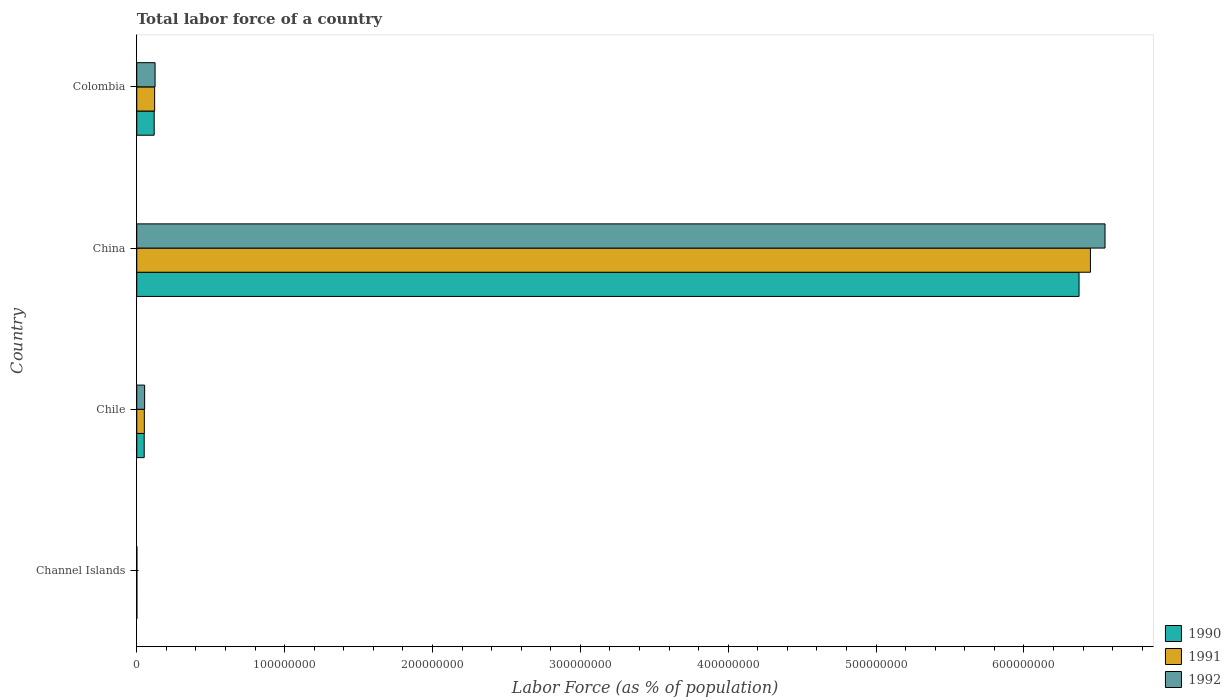How many bars are there on the 1st tick from the bottom?
Provide a succinct answer. 3. What is the percentage of labor force in 1990 in Colombia?
Offer a terse response. 1.18e+07. Across all countries, what is the maximum percentage of labor force in 1990?
Your response must be concise. 6.37e+08. Across all countries, what is the minimum percentage of labor force in 1990?
Offer a terse response. 6.71e+04. In which country was the percentage of labor force in 1991 minimum?
Keep it short and to the point. Channel Islands. What is the total percentage of labor force in 1991 in the graph?
Give a very brief answer. 6.62e+08. What is the difference between the percentage of labor force in 1992 in China and that in Colombia?
Provide a succinct answer. 6.43e+08. What is the difference between the percentage of labor force in 1992 in Chile and the percentage of labor force in 1991 in Colombia?
Give a very brief answer. -6.77e+06. What is the average percentage of labor force in 1990 per country?
Offer a terse response. 1.64e+08. What is the difference between the percentage of labor force in 1991 and percentage of labor force in 1992 in Channel Islands?
Your answer should be compact. -822. What is the ratio of the percentage of labor force in 1990 in Channel Islands to that in China?
Provide a succinct answer. 0. Is the percentage of labor force in 1992 in Channel Islands less than that in Chile?
Offer a very short reply. Yes. Is the difference between the percentage of labor force in 1991 in China and Colombia greater than the difference between the percentage of labor force in 1992 in China and Colombia?
Provide a succinct answer. No. What is the difference between the highest and the second highest percentage of labor force in 1992?
Your answer should be compact. 6.43e+08. What is the difference between the highest and the lowest percentage of labor force in 1991?
Provide a short and direct response. 6.45e+08. In how many countries, is the percentage of labor force in 1991 greater than the average percentage of labor force in 1991 taken over all countries?
Keep it short and to the point. 1. Is the sum of the percentage of labor force in 1992 in China and Colombia greater than the maximum percentage of labor force in 1991 across all countries?
Make the answer very short. Yes. Is it the case that in every country, the sum of the percentage of labor force in 1992 and percentage of labor force in 1990 is greater than the percentage of labor force in 1991?
Keep it short and to the point. Yes. How many bars are there?
Make the answer very short. 12. Does the graph contain grids?
Provide a short and direct response. No. Where does the legend appear in the graph?
Provide a short and direct response. Bottom right. How many legend labels are there?
Offer a terse response. 3. How are the legend labels stacked?
Provide a succinct answer. Vertical. What is the title of the graph?
Your answer should be compact. Total labor force of a country. What is the label or title of the X-axis?
Your answer should be very brief. Labor Force (as % of population). What is the Labor Force (as % of population) in 1990 in Channel Islands?
Your answer should be compact. 6.71e+04. What is the Labor Force (as % of population) of 1991 in Channel Islands?
Ensure brevity in your answer.  6.79e+04. What is the Labor Force (as % of population) of 1992 in Channel Islands?
Offer a very short reply. 6.87e+04. What is the Labor Force (as % of population) in 1990 in Chile?
Give a very brief answer. 5.03e+06. What is the Labor Force (as % of population) of 1991 in Chile?
Ensure brevity in your answer.  5.11e+06. What is the Labor Force (as % of population) in 1992 in Chile?
Your answer should be very brief. 5.32e+06. What is the Labor Force (as % of population) in 1990 in China?
Keep it short and to the point. 6.37e+08. What is the Labor Force (as % of population) of 1991 in China?
Make the answer very short. 6.45e+08. What is the Labor Force (as % of population) in 1992 in China?
Keep it short and to the point. 6.55e+08. What is the Labor Force (as % of population) in 1990 in Colombia?
Provide a succinct answer. 1.18e+07. What is the Labor Force (as % of population) of 1991 in Colombia?
Make the answer very short. 1.21e+07. What is the Labor Force (as % of population) of 1992 in Colombia?
Provide a succinct answer. 1.24e+07. Across all countries, what is the maximum Labor Force (as % of population) in 1990?
Offer a very short reply. 6.37e+08. Across all countries, what is the maximum Labor Force (as % of population) in 1991?
Make the answer very short. 6.45e+08. Across all countries, what is the maximum Labor Force (as % of population) in 1992?
Keep it short and to the point. 6.55e+08. Across all countries, what is the minimum Labor Force (as % of population) of 1990?
Make the answer very short. 6.71e+04. Across all countries, what is the minimum Labor Force (as % of population) in 1991?
Offer a terse response. 6.79e+04. Across all countries, what is the minimum Labor Force (as % of population) in 1992?
Provide a short and direct response. 6.87e+04. What is the total Labor Force (as % of population) in 1990 in the graph?
Keep it short and to the point. 6.54e+08. What is the total Labor Force (as % of population) of 1991 in the graph?
Your answer should be very brief. 6.62e+08. What is the total Labor Force (as % of population) of 1992 in the graph?
Give a very brief answer. 6.73e+08. What is the difference between the Labor Force (as % of population) of 1990 in Channel Islands and that in Chile?
Make the answer very short. -4.96e+06. What is the difference between the Labor Force (as % of population) of 1991 in Channel Islands and that in Chile?
Provide a succinct answer. -5.04e+06. What is the difference between the Labor Force (as % of population) of 1992 in Channel Islands and that in Chile?
Give a very brief answer. -5.25e+06. What is the difference between the Labor Force (as % of population) in 1990 in Channel Islands and that in China?
Make the answer very short. -6.37e+08. What is the difference between the Labor Force (as % of population) of 1991 in Channel Islands and that in China?
Offer a very short reply. -6.45e+08. What is the difference between the Labor Force (as % of population) of 1992 in Channel Islands and that in China?
Offer a very short reply. -6.55e+08. What is the difference between the Labor Force (as % of population) in 1990 in Channel Islands and that in Colombia?
Give a very brief answer. -1.17e+07. What is the difference between the Labor Force (as % of population) of 1991 in Channel Islands and that in Colombia?
Your answer should be compact. -1.20e+07. What is the difference between the Labor Force (as % of population) of 1992 in Channel Islands and that in Colombia?
Provide a short and direct response. -1.23e+07. What is the difference between the Labor Force (as % of population) in 1990 in Chile and that in China?
Offer a very short reply. -6.32e+08. What is the difference between the Labor Force (as % of population) in 1991 in Chile and that in China?
Provide a succinct answer. -6.40e+08. What is the difference between the Labor Force (as % of population) in 1992 in Chile and that in China?
Your response must be concise. -6.50e+08. What is the difference between the Labor Force (as % of population) of 1990 in Chile and that in Colombia?
Provide a succinct answer. -6.75e+06. What is the difference between the Labor Force (as % of population) in 1991 in Chile and that in Colombia?
Offer a terse response. -6.98e+06. What is the difference between the Labor Force (as % of population) of 1992 in Chile and that in Colombia?
Provide a short and direct response. -7.06e+06. What is the difference between the Labor Force (as % of population) of 1990 in China and that in Colombia?
Give a very brief answer. 6.26e+08. What is the difference between the Labor Force (as % of population) of 1991 in China and that in Colombia?
Your response must be concise. 6.33e+08. What is the difference between the Labor Force (as % of population) in 1992 in China and that in Colombia?
Offer a very short reply. 6.43e+08. What is the difference between the Labor Force (as % of population) of 1990 in Channel Islands and the Labor Force (as % of population) of 1991 in Chile?
Offer a very short reply. -5.04e+06. What is the difference between the Labor Force (as % of population) in 1990 in Channel Islands and the Labor Force (as % of population) in 1992 in Chile?
Ensure brevity in your answer.  -5.25e+06. What is the difference between the Labor Force (as % of population) of 1991 in Channel Islands and the Labor Force (as % of population) of 1992 in Chile?
Provide a short and direct response. -5.25e+06. What is the difference between the Labor Force (as % of population) of 1990 in Channel Islands and the Labor Force (as % of population) of 1991 in China?
Keep it short and to the point. -6.45e+08. What is the difference between the Labor Force (as % of population) in 1990 in Channel Islands and the Labor Force (as % of population) in 1992 in China?
Keep it short and to the point. -6.55e+08. What is the difference between the Labor Force (as % of population) of 1991 in Channel Islands and the Labor Force (as % of population) of 1992 in China?
Give a very brief answer. -6.55e+08. What is the difference between the Labor Force (as % of population) of 1990 in Channel Islands and the Labor Force (as % of population) of 1991 in Colombia?
Provide a succinct answer. -1.20e+07. What is the difference between the Labor Force (as % of population) in 1990 in Channel Islands and the Labor Force (as % of population) in 1992 in Colombia?
Provide a short and direct response. -1.23e+07. What is the difference between the Labor Force (as % of population) of 1991 in Channel Islands and the Labor Force (as % of population) of 1992 in Colombia?
Keep it short and to the point. -1.23e+07. What is the difference between the Labor Force (as % of population) of 1990 in Chile and the Labor Force (as % of population) of 1991 in China?
Keep it short and to the point. -6.40e+08. What is the difference between the Labor Force (as % of population) of 1990 in Chile and the Labor Force (as % of population) of 1992 in China?
Offer a terse response. -6.50e+08. What is the difference between the Labor Force (as % of population) of 1991 in Chile and the Labor Force (as % of population) of 1992 in China?
Your answer should be compact. -6.50e+08. What is the difference between the Labor Force (as % of population) of 1990 in Chile and the Labor Force (as % of population) of 1991 in Colombia?
Your answer should be very brief. -7.06e+06. What is the difference between the Labor Force (as % of population) of 1990 in Chile and the Labor Force (as % of population) of 1992 in Colombia?
Keep it short and to the point. -7.36e+06. What is the difference between the Labor Force (as % of population) of 1991 in Chile and the Labor Force (as % of population) of 1992 in Colombia?
Provide a succinct answer. -7.27e+06. What is the difference between the Labor Force (as % of population) of 1990 in China and the Labor Force (as % of population) of 1991 in Colombia?
Offer a very short reply. 6.25e+08. What is the difference between the Labor Force (as % of population) of 1990 in China and the Labor Force (as % of population) of 1992 in Colombia?
Give a very brief answer. 6.25e+08. What is the difference between the Labor Force (as % of population) in 1991 in China and the Labor Force (as % of population) in 1992 in Colombia?
Give a very brief answer. 6.33e+08. What is the average Labor Force (as % of population) of 1990 per country?
Offer a very short reply. 1.64e+08. What is the average Labor Force (as % of population) of 1991 per country?
Keep it short and to the point. 1.66e+08. What is the average Labor Force (as % of population) of 1992 per country?
Provide a succinct answer. 1.68e+08. What is the difference between the Labor Force (as % of population) of 1990 and Labor Force (as % of population) of 1991 in Channel Islands?
Provide a succinct answer. -765. What is the difference between the Labor Force (as % of population) in 1990 and Labor Force (as % of population) in 1992 in Channel Islands?
Offer a terse response. -1587. What is the difference between the Labor Force (as % of population) in 1991 and Labor Force (as % of population) in 1992 in Channel Islands?
Offer a terse response. -822. What is the difference between the Labor Force (as % of population) of 1990 and Labor Force (as % of population) of 1991 in Chile?
Your answer should be compact. -8.28e+04. What is the difference between the Labor Force (as % of population) in 1990 and Labor Force (as % of population) in 1992 in Chile?
Provide a succinct answer. -2.95e+05. What is the difference between the Labor Force (as % of population) in 1991 and Labor Force (as % of population) in 1992 in Chile?
Your answer should be very brief. -2.12e+05. What is the difference between the Labor Force (as % of population) in 1990 and Labor Force (as % of population) in 1991 in China?
Offer a terse response. -7.70e+06. What is the difference between the Labor Force (as % of population) of 1990 and Labor Force (as % of population) of 1992 in China?
Provide a succinct answer. -1.76e+07. What is the difference between the Labor Force (as % of population) in 1991 and Labor Force (as % of population) in 1992 in China?
Your response must be concise. -9.86e+06. What is the difference between the Labor Force (as % of population) in 1990 and Labor Force (as % of population) in 1991 in Colombia?
Provide a succinct answer. -3.13e+05. What is the difference between the Labor Force (as % of population) in 1990 and Labor Force (as % of population) in 1992 in Colombia?
Keep it short and to the point. -6.06e+05. What is the difference between the Labor Force (as % of population) in 1991 and Labor Force (as % of population) in 1992 in Colombia?
Provide a succinct answer. -2.93e+05. What is the ratio of the Labor Force (as % of population) of 1990 in Channel Islands to that in Chile?
Make the answer very short. 0.01. What is the ratio of the Labor Force (as % of population) of 1991 in Channel Islands to that in Chile?
Provide a short and direct response. 0.01. What is the ratio of the Labor Force (as % of population) in 1992 in Channel Islands to that in Chile?
Keep it short and to the point. 0.01. What is the ratio of the Labor Force (as % of population) in 1991 in Channel Islands to that in China?
Ensure brevity in your answer.  0. What is the ratio of the Labor Force (as % of population) in 1992 in Channel Islands to that in China?
Make the answer very short. 0. What is the ratio of the Labor Force (as % of population) in 1990 in Channel Islands to that in Colombia?
Ensure brevity in your answer.  0.01. What is the ratio of the Labor Force (as % of population) in 1991 in Channel Islands to that in Colombia?
Provide a succinct answer. 0.01. What is the ratio of the Labor Force (as % of population) of 1992 in Channel Islands to that in Colombia?
Ensure brevity in your answer.  0.01. What is the ratio of the Labor Force (as % of population) of 1990 in Chile to that in China?
Make the answer very short. 0.01. What is the ratio of the Labor Force (as % of population) in 1991 in Chile to that in China?
Provide a succinct answer. 0.01. What is the ratio of the Labor Force (as % of population) of 1992 in Chile to that in China?
Your answer should be very brief. 0.01. What is the ratio of the Labor Force (as % of population) in 1990 in Chile to that in Colombia?
Make the answer very short. 0.43. What is the ratio of the Labor Force (as % of population) in 1991 in Chile to that in Colombia?
Give a very brief answer. 0.42. What is the ratio of the Labor Force (as % of population) in 1992 in Chile to that in Colombia?
Your answer should be very brief. 0.43. What is the ratio of the Labor Force (as % of population) of 1990 in China to that in Colombia?
Make the answer very short. 54.12. What is the ratio of the Labor Force (as % of population) in 1991 in China to that in Colombia?
Keep it short and to the point. 53.36. What is the ratio of the Labor Force (as % of population) in 1992 in China to that in Colombia?
Your response must be concise. 52.89. What is the difference between the highest and the second highest Labor Force (as % of population) in 1990?
Your answer should be very brief. 6.26e+08. What is the difference between the highest and the second highest Labor Force (as % of population) of 1991?
Provide a short and direct response. 6.33e+08. What is the difference between the highest and the second highest Labor Force (as % of population) in 1992?
Keep it short and to the point. 6.43e+08. What is the difference between the highest and the lowest Labor Force (as % of population) in 1990?
Ensure brevity in your answer.  6.37e+08. What is the difference between the highest and the lowest Labor Force (as % of population) in 1991?
Ensure brevity in your answer.  6.45e+08. What is the difference between the highest and the lowest Labor Force (as % of population) in 1992?
Provide a succinct answer. 6.55e+08. 